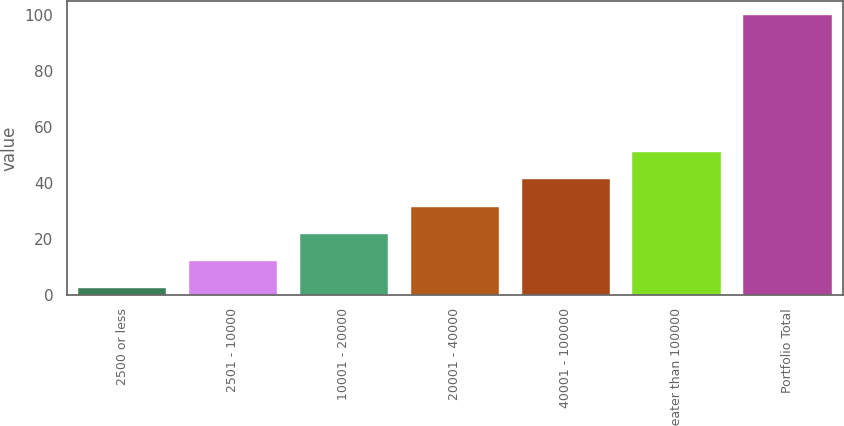Convert chart to OTSL. <chart><loc_0><loc_0><loc_500><loc_500><bar_chart><fcel>2500 or less<fcel>2501 - 10000<fcel>10001 - 20000<fcel>20001 - 40000<fcel>40001 - 100000<fcel>Greater than 100000<fcel>Portfolio Total<nl><fcel>2.4<fcel>12.16<fcel>21.92<fcel>31.68<fcel>41.44<fcel>51.2<fcel>100<nl></chart> 